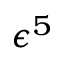Convert formula to latex. <formula><loc_0><loc_0><loc_500><loc_500>\epsilon ^ { 5 }</formula> 